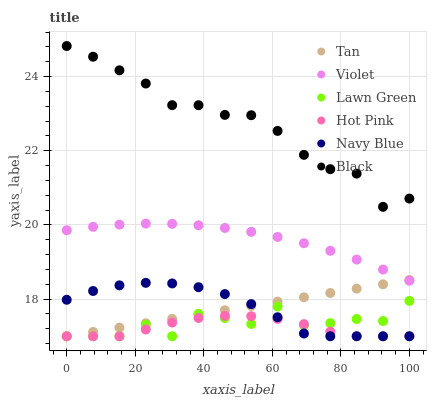Does Hot Pink have the minimum area under the curve?
Answer yes or no. Yes. Does Black have the maximum area under the curve?
Answer yes or no. Yes. Does Navy Blue have the minimum area under the curve?
Answer yes or no. No. Does Navy Blue have the maximum area under the curve?
Answer yes or no. No. Is Tan the smoothest?
Answer yes or no. Yes. Is Lawn Green the roughest?
Answer yes or no. Yes. Is Navy Blue the smoothest?
Answer yes or no. No. Is Navy Blue the roughest?
Answer yes or no. No. Does Lawn Green have the lowest value?
Answer yes or no. Yes. Does Black have the lowest value?
Answer yes or no. No. Does Black have the highest value?
Answer yes or no. Yes. Does Navy Blue have the highest value?
Answer yes or no. No. Is Navy Blue less than Violet?
Answer yes or no. Yes. Is Black greater than Tan?
Answer yes or no. Yes. Does Hot Pink intersect Lawn Green?
Answer yes or no. Yes. Is Hot Pink less than Lawn Green?
Answer yes or no. No. Is Hot Pink greater than Lawn Green?
Answer yes or no. No. Does Navy Blue intersect Violet?
Answer yes or no. No. 